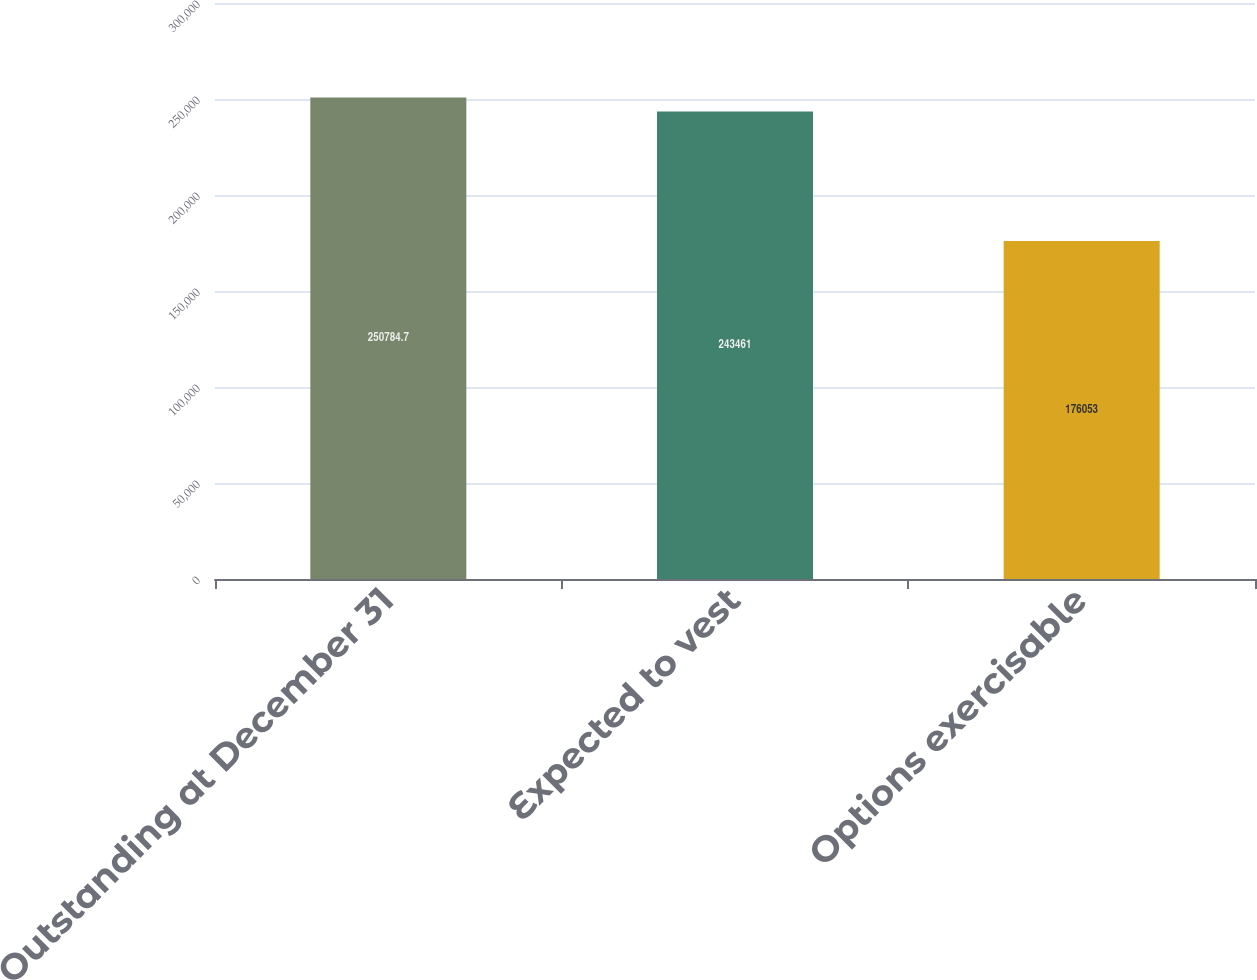Convert chart. <chart><loc_0><loc_0><loc_500><loc_500><bar_chart><fcel>Outstanding at December 31<fcel>Expected to vest<fcel>Options exercisable<nl><fcel>250785<fcel>243461<fcel>176053<nl></chart> 